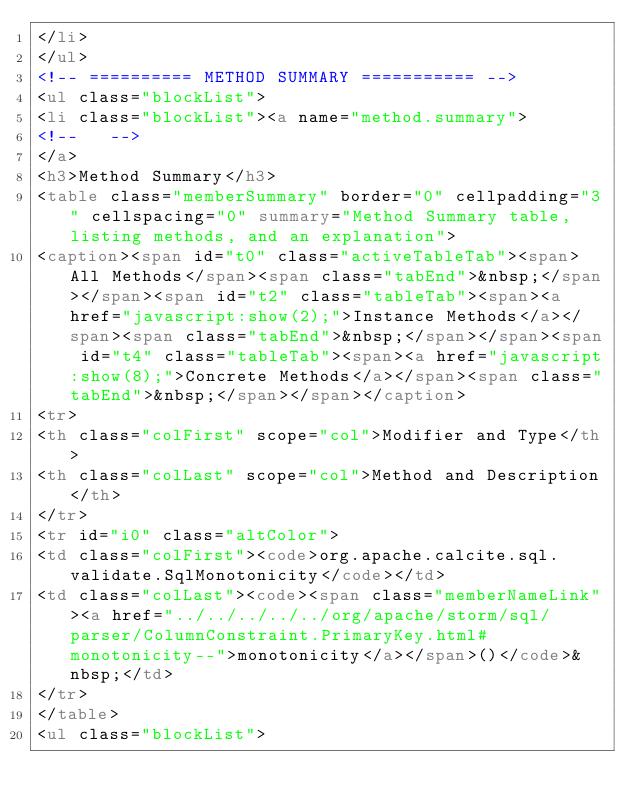<code> <loc_0><loc_0><loc_500><loc_500><_HTML_></li>
</ul>
<!-- ========== METHOD SUMMARY =========== -->
<ul class="blockList">
<li class="blockList"><a name="method.summary">
<!--   -->
</a>
<h3>Method Summary</h3>
<table class="memberSummary" border="0" cellpadding="3" cellspacing="0" summary="Method Summary table, listing methods, and an explanation">
<caption><span id="t0" class="activeTableTab"><span>All Methods</span><span class="tabEnd">&nbsp;</span></span><span id="t2" class="tableTab"><span><a href="javascript:show(2);">Instance Methods</a></span><span class="tabEnd">&nbsp;</span></span><span id="t4" class="tableTab"><span><a href="javascript:show(8);">Concrete Methods</a></span><span class="tabEnd">&nbsp;</span></span></caption>
<tr>
<th class="colFirst" scope="col">Modifier and Type</th>
<th class="colLast" scope="col">Method and Description</th>
</tr>
<tr id="i0" class="altColor">
<td class="colFirst"><code>org.apache.calcite.sql.validate.SqlMonotonicity</code></td>
<td class="colLast"><code><span class="memberNameLink"><a href="../../../../../org/apache/storm/sql/parser/ColumnConstraint.PrimaryKey.html#monotonicity--">monotonicity</a></span>()</code>&nbsp;</td>
</tr>
</table>
<ul class="blockList"></code> 